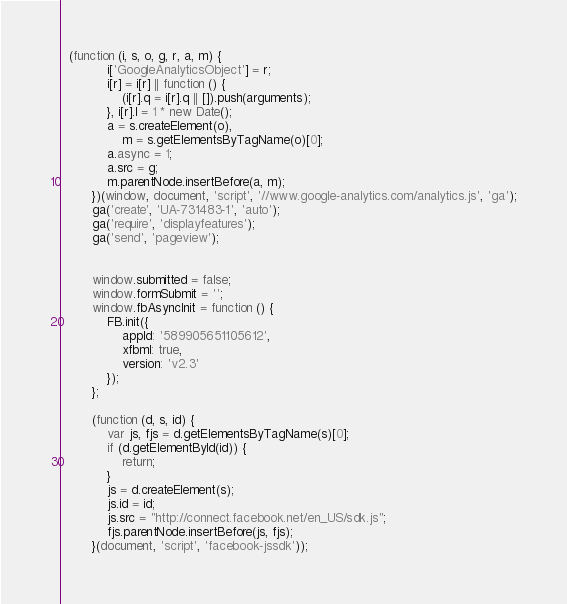Convert code to text. <code><loc_0><loc_0><loc_500><loc_500><_JavaScript_>  (function (i, s, o, g, r, a, m) {
            i['GoogleAnalyticsObject'] = r;
            i[r] = i[r] || function () {
                (i[r].q = i[r].q || []).push(arguments);
            }, i[r].l = 1 * new Date();
            a = s.createElement(o),
                m = s.getElementsByTagName(o)[0];
            a.async = 1;
            a.src = g;
            m.parentNode.insertBefore(a, m);
        })(window, document, 'script', '//www.google-analytics.com/analytics.js', 'ga');
        ga('create', 'UA-731483-1', 'auto');
        ga('require', 'displayfeatures');
        ga('send', 'pageview');


        window.submitted = false;
        window.formSubmit = '';
        window.fbAsyncInit = function () {
            FB.init({
                appId: '589905651105612',
                xfbml: true,
                version: 'v2.3'
            });
        };

        (function (d, s, id) {
            var js, fjs = d.getElementsByTagName(s)[0];
            if (d.getElementById(id)) {
                return;
            }
            js = d.createElement(s);
            js.id = id;
            js.src = "http://connect.facebook.net/en_US/sdk.js";
            fjs.parentNode.insertBefore(js, fjs);
        }(document, 'script', 'facebook-jssdk'));
</code> 